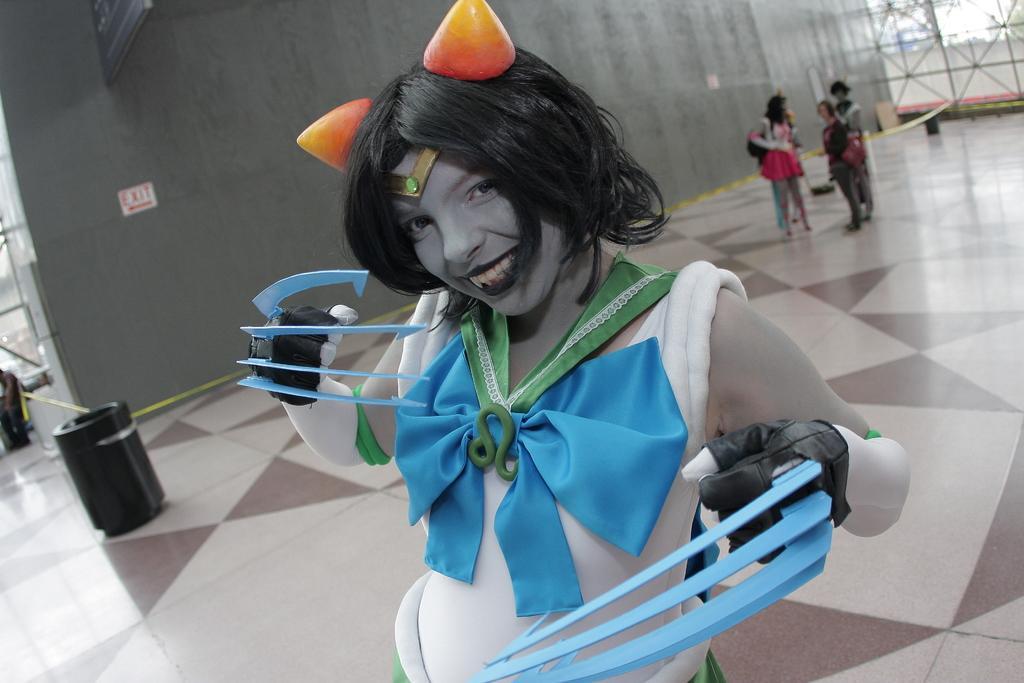Describe this image in one or two sentences. In the image there is a woman, she is wearing different costume and vampire makeup, behind the woman there is a wall and on the right side there are a group of people standing in front of the wall. 